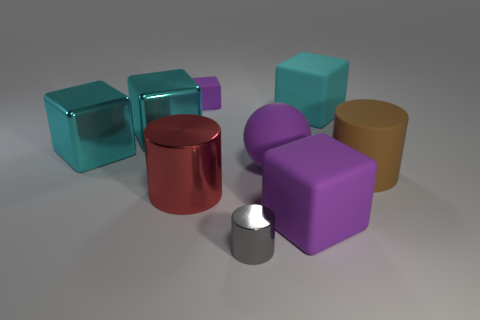Subtract all purple balls. How many cyan cubes are left? 3 Subtract all big purple rubber cubes. How many cubes are left? 4 Subtract 2 cubes. How many cubes are left? 3 Subtract all gray cubes. Subtract all brown cylinders. How many cubes are left? 5 Add 1 gray metal cylinders. How many objects exist? 10 Subtract all blocks. How many objects are left? 4 Subtract 0 red blocks. How many objects are left? 9 Subtract all large cylinders. Subtract all large brown metallic cubes. How many objects are left? 7 Add 8 cyan matte blocks. How many cyan matte blocks are left? 9 Add 4 tiny shiny cylinders. How many tiny shiny cylinders exist? 5 